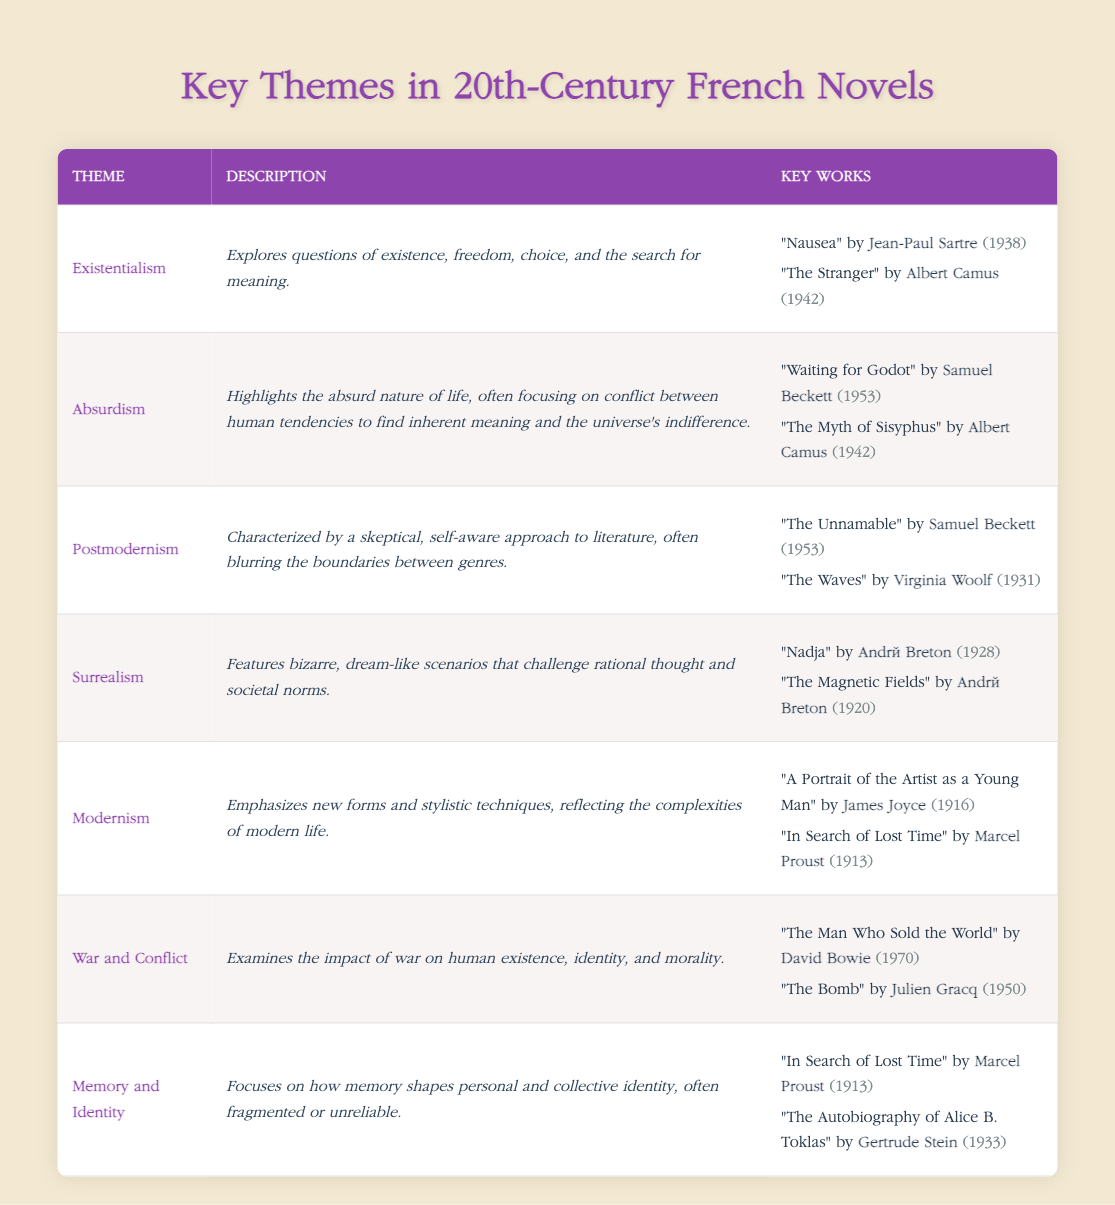What is the theme that explores questions of existence, freedom, choice, and the search for meaning? The table specifies that the theme related to these concepts is "Existentialism."
Answer: Existentialism Which author wrote "Nausea"? According to the table, "Nausea" is written by Jean-Paul Sartre.
Answer: Jean-Paul Sartre Are there any key works by Albert Camus that discuss Absurdism? Yes, the table lists "The Myth of Sisyphus" and "The Stranger" as key works associated with Albert Camus and Absurdism.
Answer: Yes What is the publication year of "In Search of Lost Time"? The table indicates that "In Search of Lost Time" was published in 1913.
Answer: 1913 Which two themes are associated with Marcel Proust's "In Search of Lost Time"? The table indicates that "In Search of Lost Time" is related to the themes of "Modernism" and "Memory and Identity."
Answer: Modernism and Memory and Identity How many key works written by André Breton are listed, and what are their titles? The table lists two key works by André Breton: "Nadja" (1928) and "The Magnetic Fields" (1920), making a total of two works.
Answer: Two: "Nadja" and "The Magnetic Fields" Is "Waiting for Godot" published before or after 1950? The table shows that "Waiting for Godot" was published in 1953, which is after 1950.
Answer: After Which theme does not feature any works by Virginia Woolf? The theme "Existentialism" does not feature any works by Virginia Woolf according to the table.
Answer: Existentialism Count the total number of themes listed in the table. The table contains a total of seven themes: Existentialism, Absurdism, Postmodernism, Surrealism, Modernism, War and Conflict, and Memory and Identity, resulting in a sum of seven.
Answer: Seven 